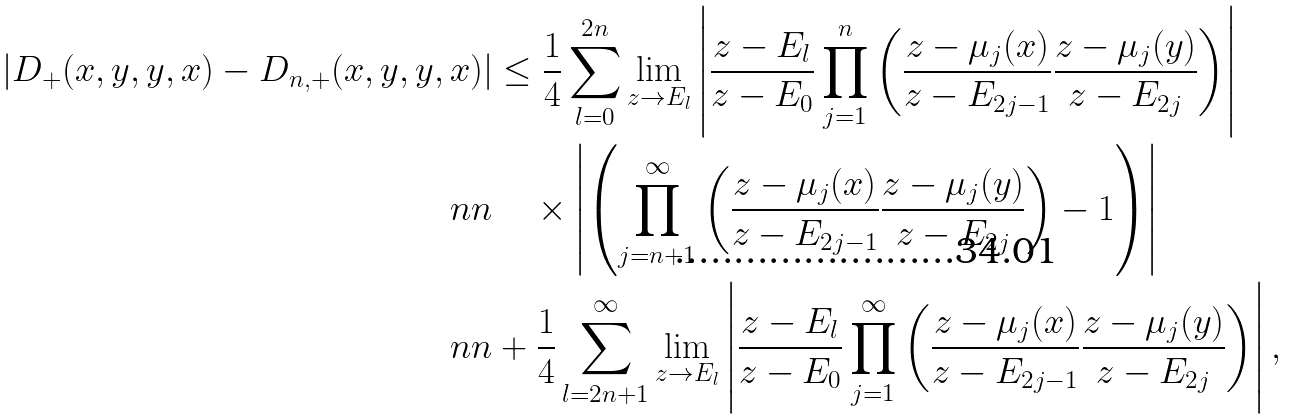Convert formula to latex. <formula><loc_0><loc_0><loc_500><loc_500>| D _ { + } ( x , y , y , x ) - D _ { n , + } ( x , y , y , x ) | & \leq \frac { 1 } { 4 } \sum _ { l = 0 } ^ { 2 n } \lim _ { z \to E _ { l } } \left | \frac { z - E _ { l } } { z - E _ { 0 } } \prod _ { j = 1 } ^ { n } \left ( \frac { z - \mu _ { j } ( x ) } { z - E _ { 2 j - 1 } } \frac { z - \mu _ { j } ( y ) } { z - E _ { 2 j } } \right ) \right | \\ \ n n & \quad \times \left | \left ( \prod _ { j = n + 1 } ^ { \infty } \left ( \frac { z - \mu _ { j } ( x ) } { z - E _ { 2 j - 1 } } \frac { z - \mu _ { j } ( y ) } { z - E _ { 2 j } } \right ) - 1 \right ) \right | \\ \ n n & + \frac { 1 } { 4 } \sum _ { l = 2 n + 1 } ^ { \infty } \lim _ { z \to E _ { l } } \left | \frac { z - E _ { l } } { z - E _ { 0 } } \prod _ { j = 1 } ^ { \infty } \left ( \frac { z - \mu _ { j } ( x ) } { z - E _ { 2 j - 1 } } \frac { z - \mu _ { j } ( y ) } { z - E _ { 2 j } } \right ) \right | ,</formula> 